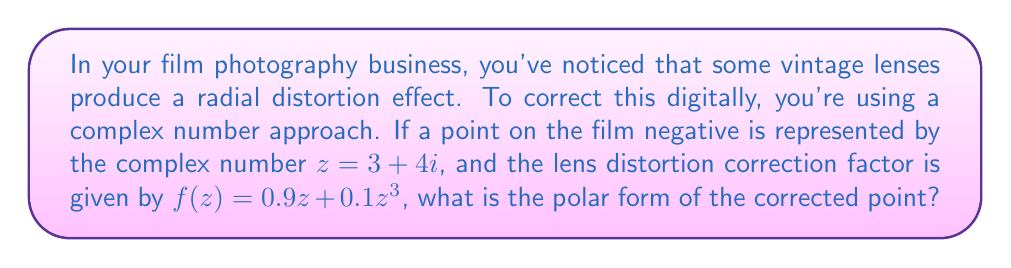Can you solve this math problem? Let's approach this step-by-step:

1) First, we need to calculate $f(z)$:
   $f(z) = 0.9z + 0.1z^3$
   
2) We know $z = 3 + 4i$. Let's calculate $z^3$:
   $z^3 = (3 + 4i)^3 = 27 + 108i - 108 - 64i = -81 + 44i$

3) Now we can substitute these into our function:
   $f(z) = 0.9(3 + 4i) + 0.1(-81 + 44i)$
   $= (2.7 + 3.6i) + (-8.1 + 4.4i)$
   $= -5.4 + 8i$

4) To convert this to polar form, we need to calculate the magnitude $r$ and the angle $\theta$:

   $r = \sqrt{(-5.4)^2 + 8^2} = \sqrt{29.16 + 64} = \sqrt{93.16} \approx 9.653$

   $\theta = \tan^{-1}(\frac{8}{-5.4}) + \pi \approx 2.165$ radians (we add $\pi$ because the real part is negative)

5) The polar form is represented as $re^{i\theta}$

Therefore, the polar form of the corrected point is approximately:

$9.653e^{2.165i}$
Answer: $9.653e^{2.165i}$ 